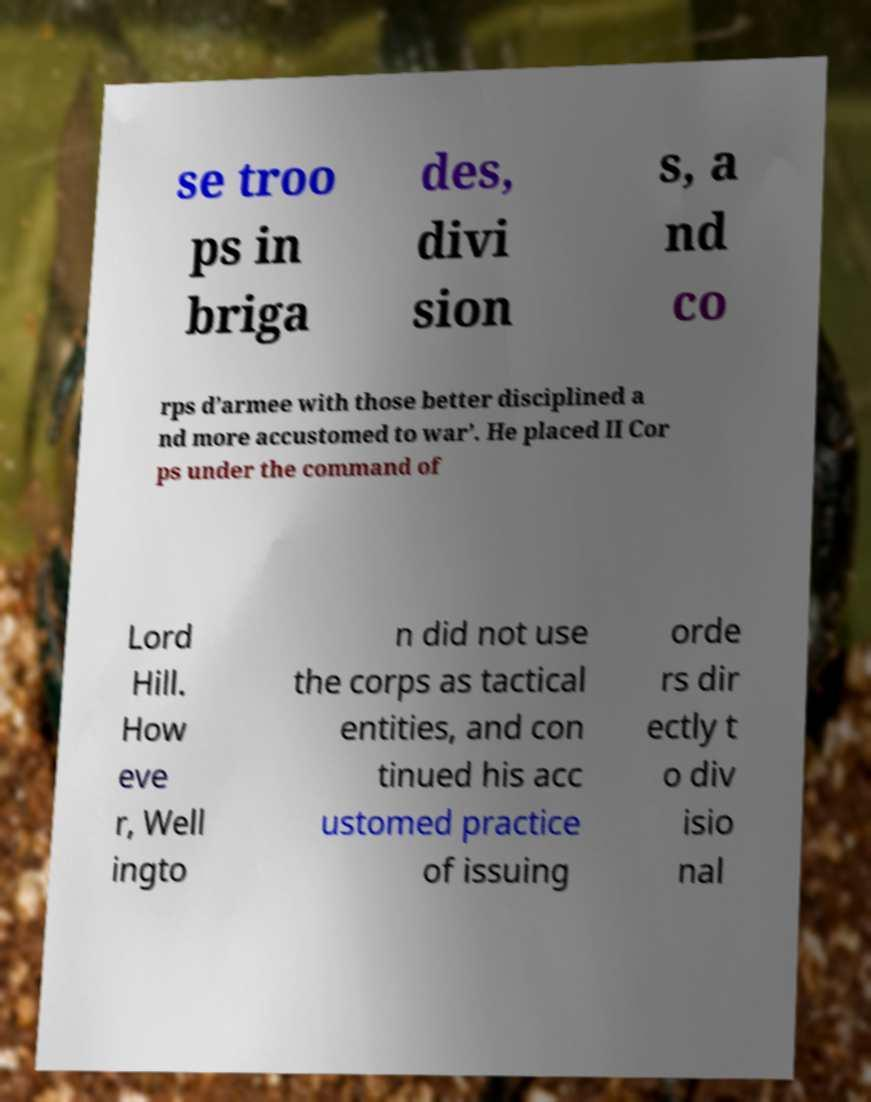Could you assist in decoding the text presented in this image and type it out clearly? se troo ps in briga des, divi sion s, a nd co rps d’armee with those better disciplined a nd more accustomed to war’. He placed II Cor ps under the command of Lord Hill. How eve r, Well ingto n did not use the corps as tactical entities, and con tinued his acc ustomed practice of issuing orde rs dir ectly t o div isio nal 